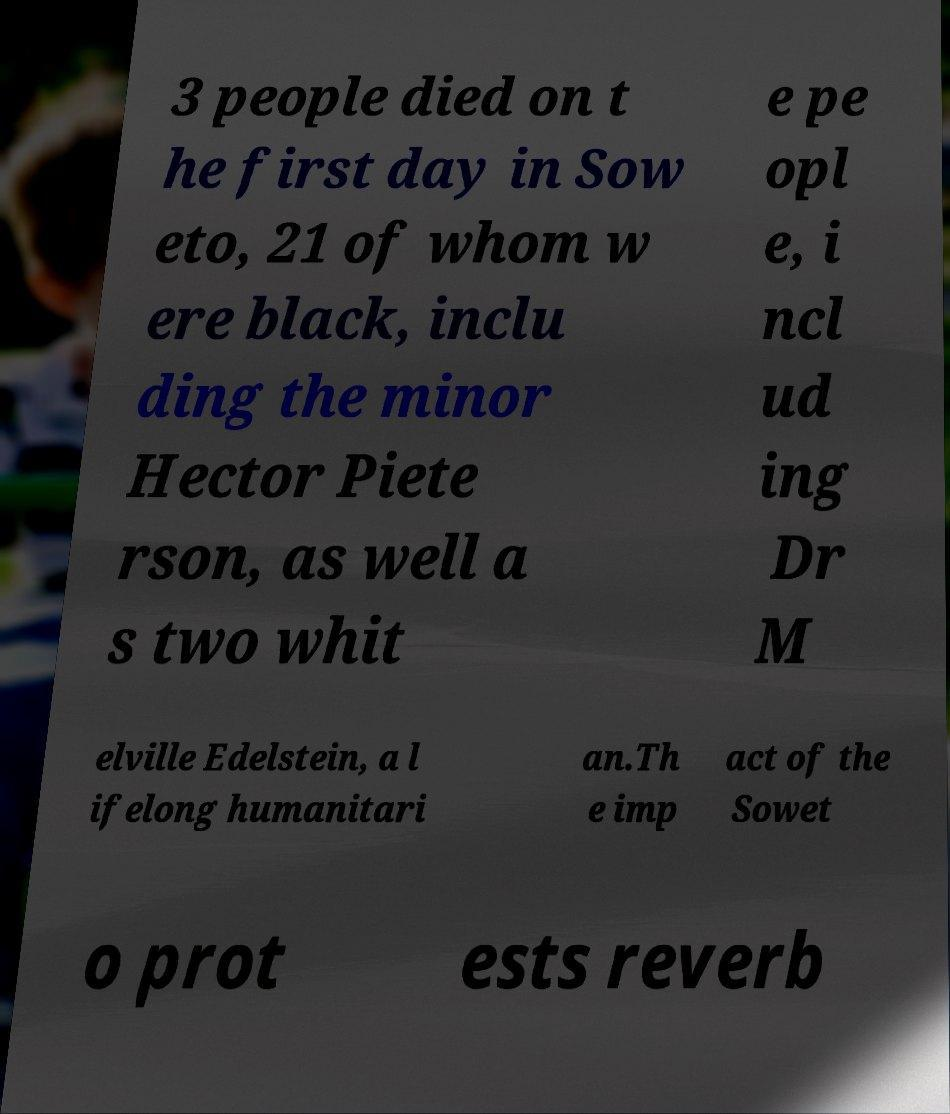Could you assist in decoding the text presented in this image and type it out clearly? 3 people died on t he first day in Sow eto, 21 of whom w ere black, inclu ding the minor Hector Piete rson, as well a s two whit e pe opl e, i ncl ud ing Dr M elville Edelstein, a l ifelong humanitari an.Th e imp act of the Sowet o prot ests reverb 